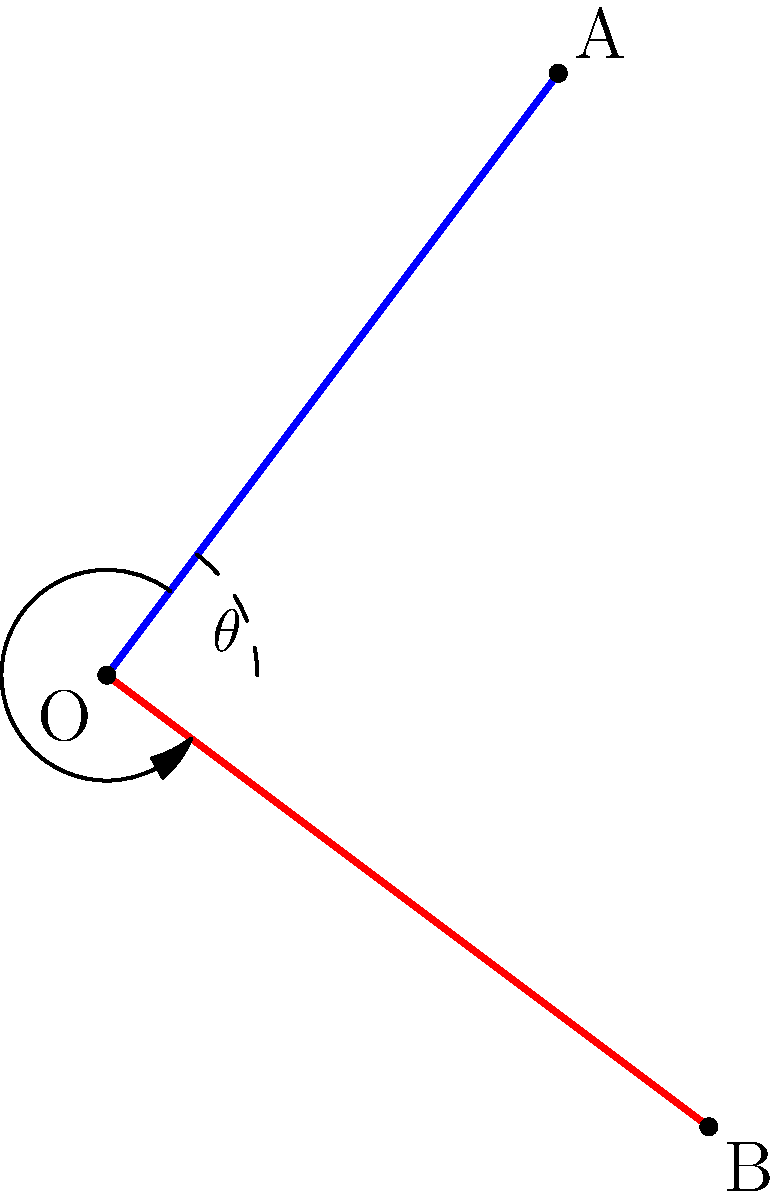Two paths diverge from point O, one leading to point A and another to point B. The coordinates of the points are O(0,0), A(3,4), and B(4,-3). Calculate the angle $\theta$ between these two paths, representing different life choices. Round your answer to the nearest degree. To find the angle between two vectors, we can use the dot product formula:

1) First, let's define our vectors:
   $\vec{OA} = (3,4)$ and $\vec{OB} = (4,-3)$

2) The dot product formula states:
   $\cos \theta = \frac{\vec{OA} \cdot \vec{OB}}{|\vec{OA}||\vec{OB}|}$

3) Calculate the dot product $\vec{OA} \cdot \vec{OB}$:
   $\vec{OA} \cdot \vec{OB} = 3(4) + 4(-3) = 12 - 12 = 0$

4) Calculate the magnitudes:
   $|\vec{OA}| = \sqrt{3^2 + 4^2} = \sqrt{25} = 5$
   $|\vec{OB}| = \sqrt{4^2 + (-3)^2} = \sqrt{25} = 5$

5) Substitute into the formula:
   $\cos \theta = \frac{0}{5 \cdot 5} = 0$

6) Solve for $\theta$:
   $\theta = \arccos(0) = 90°$

Therefore, the angle between the two paths is 90°.
Answer: 90° 